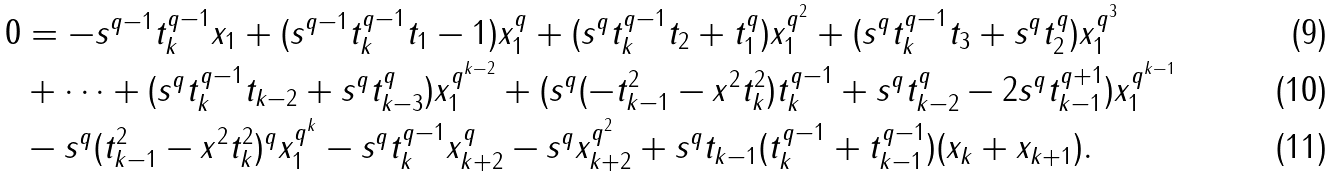<formula> <loc_0><loc_0><loc_500><loc_500>0 & = - s ^ { q - 1 } t _ { k } ^ { q - 1 } x _ { 1 } + ( s ^ { q - 1 } t _ { k } ^ { q - 1 } t _ { 1 } - 1 ) x _ { 1 } ^ { q } + ( s ^ { q } t _ { k } ^ { q - 1 } t _ { 2 } + t _ { 1 } ^ { q } ) x _ { 1 } ^ { q ^ { 2 } } + ( s ^ { q } t _ { k } ^ { q - 1 } t _ { 3 } + s ^ { q } t _ { 2 } ^ { q } ) x _ { 1 } ^ { q ^ { 3 } } \\ & + \dots + ( s ^ { q } t _ { k } ^ { q - 1 } t _ { k - 2 } + s ^ { q } t _ { k - 3 } ^ { q } ) x _ { 1 } ^ { q ^ { k - 2 } } + ( s ^ { q } ( - t _ { k - 1 } ^ { 2 } - x ^ { 2 } t _ { k } ^ { 2 } ) t _ { k } ^ { q - 1 } + s ^ { q } t _ { k - 2 } ^ { q } - 2 s ^ { q } t _ { k - 1 } ^ { q + 1 } ) x _ { 1 } ^ { q ^ { k - 1 } } \\ & - s ^ { q } ( t _ { k - 1 } ^ { 2 } - x ^ { 2 } t _ { k } ^ { 2 } ) ^ { q } x _ { 1 } ^ { q ^ { k } } - s ^ { q } t _ { k } ^ { q - 1 } x _ { k + 2 } ^ { q } - s ^ { q } x _ { k + 2 } ^ { q ^ { 2 } } + s ^ { q } t _ { k - 1 } ( t _ { k } ^ { q - 1 } + t _ { k - 1 } ^ { q - 1 } ) ( x _ { k } + x _ { k + 1 } ) .</formula> 